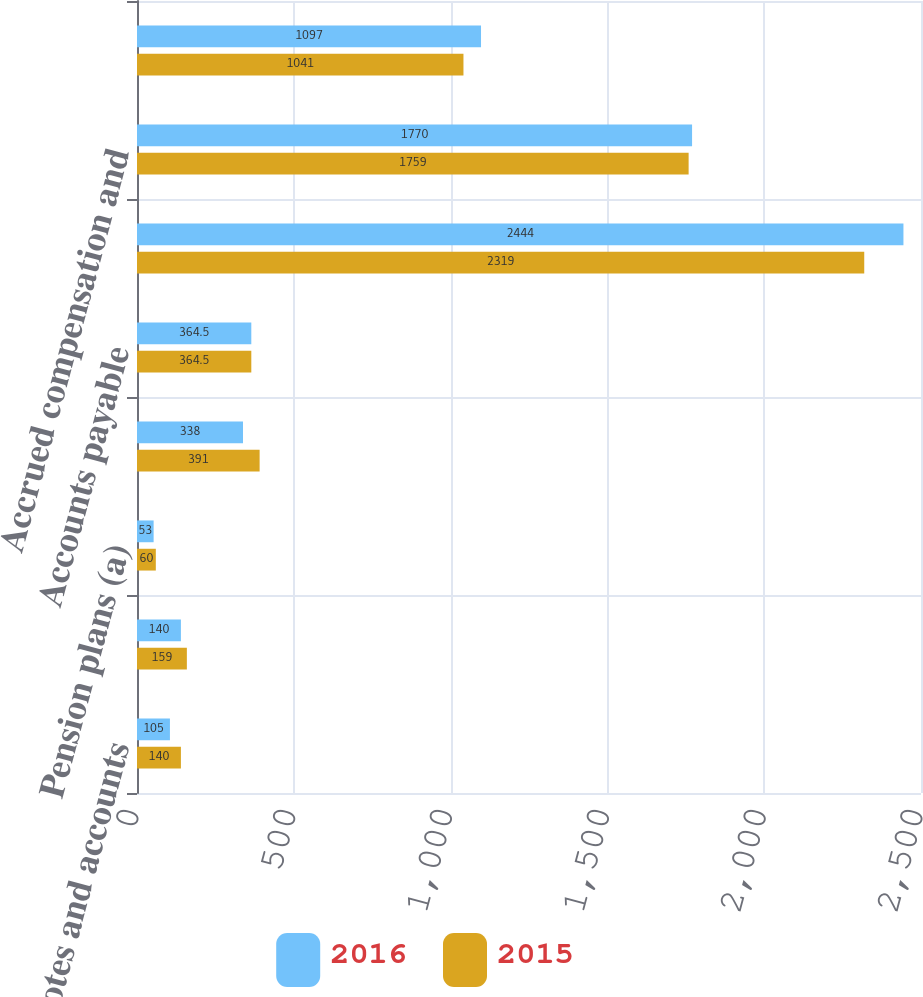<chart> <loc_0><loc_0><loc_500><loc_500><stacked_bar_chart><ecel><fcel>Noncurrent notes and accounts<fcel>Deferred marketplace spending<fcel>Pension plans (a)<fcel>Other<fcel>Accounts payable<fcel>Accrued marketplace spending<fcel>Accrued compensation and<fcel>Dividends payable<nl><fcel>2016<fcel>105<fcel>140<fcel>53<fcel>338<fcel>364.5<fcel>2444<fcel>1770<fcel>1097<nl><fcel>2015<fcel>140<fcel>159<fcel>60<fcel>391<fcel>364.5<fcel>2319<fcel>1759<fcel>1041<nl></chart> 